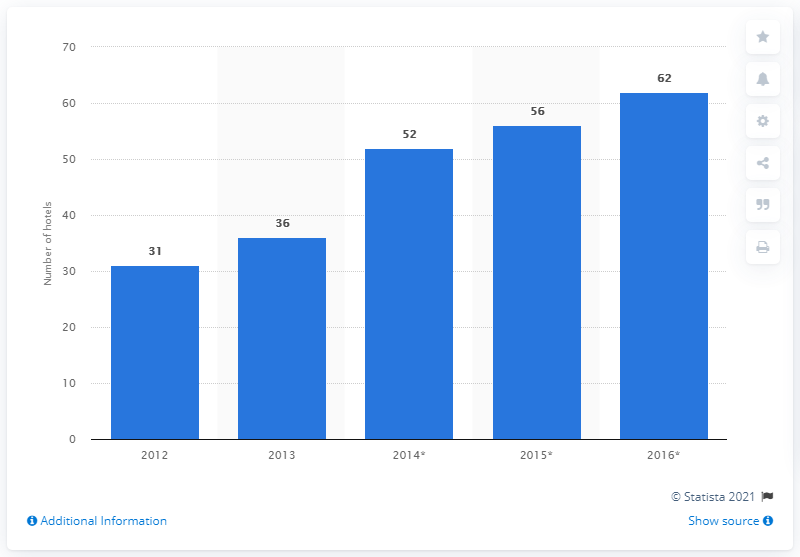Draw attention to some important aspects in this diagram. In 2016, it was forecasted that 62 new hotels would open in the Middle East. According to a report, in 2013, a total of 36 new hotels were opened in the Middle Eastern hotel market. 